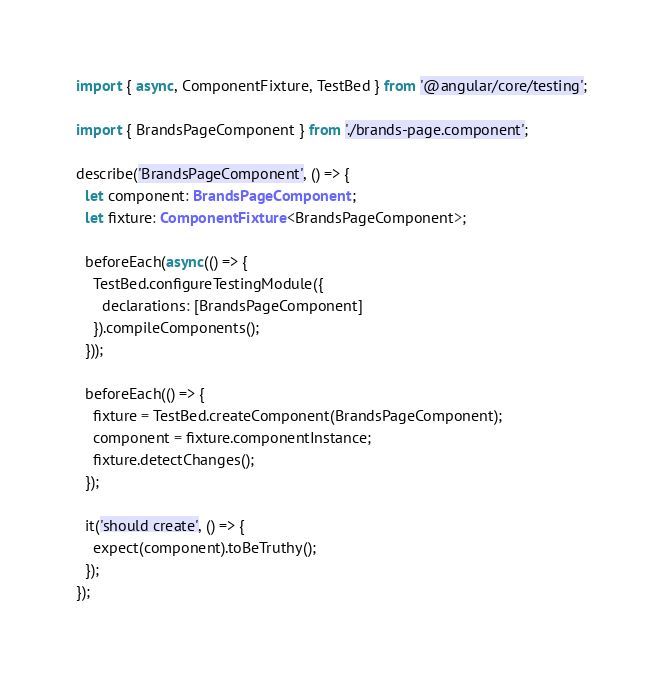Convert code to text. <code><loc_0><loc_0><loc_500><loc_500><_TypeScript_>import { async, ComponentFixture, TestBed } from '@angular/core/testing';

import { BrandsPageComponent } from './brands-page.component';

describe('BrandsPageComponent', () => {
  let component: BrandsPageComponent;
  let fixture: ComponentFixture<BrandsPageComponent>;

  beforeEach(async(() => {
    TestBed.configureTestingModule({
      declarations: [BrandsPageComponent]
    }).compileComponents();
  }));

  beforeEach(() => {
    fixture = TestBed.createComponent(BrandsPageComponent);
    component = fixture.componentInstance;
    fixture.detectChanges();
  });

  it('should create', () => {
    expect(component).toBeTruthy();
  });
});
</code> 